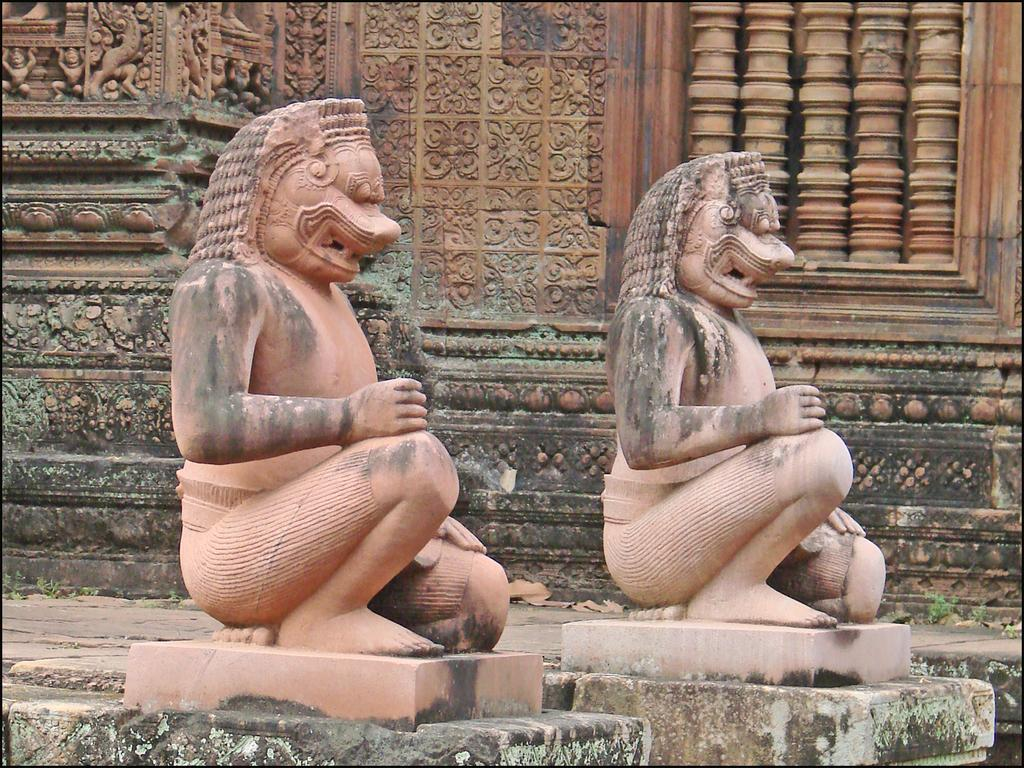What can be seen in the image? There are sculptures in the image. Can you describe the sculptures? The sculptures have different shapes. What is visible in the background of the image? There is a wall of a temple in the background of the image. What statement does the ladybug make while sitting on one of the sculptures? There is no ladybug present in the image, so it cannot make any statements while sitting on a sculpture. 